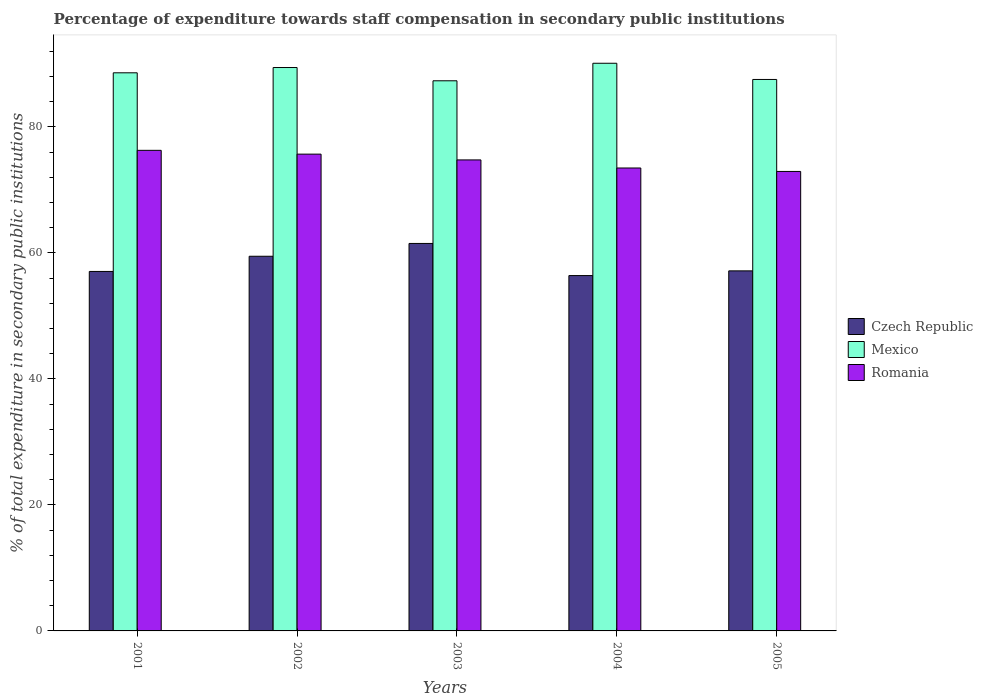How many different coloured bars are there?
Provide a short and direct response. 3. How many groups of bars are there?
Provide a succinct answer. 5. Are the number of bars per tick equal to the number of legend labels?
Make the answer very short. Yes. How many bars are there on the 1st tick from the left?
Keep it short and to the point. 3. What is the percentage of expenditure towards staff compensation in Romania in 2002?
Give a very brief answer. 75.67. Across all years, what is the maximum percentage of expenditure towards staff compensation in Mexico?
Your answer should be very brief. 90.09. Across all years, what is the minimum percentage of expenditure towards staff compensation in Czech Republic?
Offer a terse response. 56.39. In which year was the percentage of expenditure towards staff compensation in Czech Republic minimum?
Make the answer very short. 2004. What is the total percentage of expenditure towards staff compensation in Czech Republic in the graph?
Provide a short and direct response. 291.53. What is the difference between the percentage of expenditure towards staff compensation in Czech Republic in 2001 and that in 2002?
Make the answer very short. -2.41. What is the difference between the percentage of expenditure towards staff compensation in Romania in 2001 and the percentage of expenditure towards staff compensation in Czech Republic in 2004?
Your answer should be very brief. 19.88. What is the average percentage of expenditure towards staff compensation in Romania per year?
Give a very brief answer. 74.61. In the year 2002, what is the difference between the percentage of expenditure towards staff compensation in Czech Republic and percentage of expenditure towards staff compensation in Mexico?
Keep it short and to the point. -29.95. What is the ratio of the percentage of expenditure towards staff compensation in Mexico in 2001 to that in 2004?
Your response must be concise. 0.98. Is the percentage of expenditure towards staff compensation in Czech Republic in 2003 less than that in 2005?
Offer a very short reply. No. What is the difference between the highest and the second highest percentage of expenditure towards staff compensation in Mexico?
Make the answer very short. 0.68. What is the difference between the highest and the lowest percentage of expenditure towards staff compensation in Mexico?
Keep it short and to the point. 2.78. In how many years, is the percentage of expenditure towards staff compensation in Czech Republic greater than the average percentage of expenditure towards staff compensation in Czech Republic taken over all years?
Offer a very short reply. 2. Is the sum of the percentage of expenditure towards staff compensation in Romania in 2001 and 2004 greater than the maximum percentage of expenditure towards staff compensation in Czech Republic across all years?
Ensure brevity in your answer.  Yes. What does the 2nd bar from the left in 2005 represents?
Your answer should be very brief. Mexico. What does the 3rd bar from the right in 2005 represents?
Give a very brief answer. Czech Republic. Is it the case that in every year, the sum of the percentage of expenditure towards staff compensation in Czech Republic and percentage of expenditure towards staff compensation in Romania is greater than the percentage of expenditure towards staff compensation in Mexico?
Your response must be concise. Yes. How many bars are there?
Provide a succinct answer. 15. Are the values on the major ticks of Y-axis written in scientific E-notation?
Make the answer very short. No. Does the graph contain any zero values?
Your answer should be very brief. No. Where does the legend appear in the graph?
Give a very brief answer. Center right. How many legend labels are there?
Provide a short and direct response. 3. What is the title of the graph?
Provide a succinct answer. Percentage of expenditure towards staff compensation in secondary public institutions. Does "Tunisia" appear as one of the legend labels in the graph?
Make the answer very short. No. What is the label or title of the X-axis?
Ensure brevity in your answer.  Years. What is the label or title of the Y-axis?
Keep it short and to the point. % of total expenditure in secondary public institutions. What is the % of total expenditure in secondary public institutions of Czech Republic in 2001?
Provide a short and direct response. 57.05. What is the % of total expenditure in secondary public institutions in Mexico in 2001?
Make the answer very short. 88.57. What is the % of total expenditure in secondary public institutions of Romania in 2001?
Your answer should be very brief. 76.27. What is the % of total expenditure in secondary public institutions of Czech Republic in 2002?
Ensure brevity in your answer.  59.46. What is the % of total expenditure in secondary public institutions in Mexico in 2002?
Provide a succinct answer. 89.41. What is the % of total expenditure in secondary public institutions of Romania in 2002?
Provide a succinct answer. 75.67. What is the % of total expenditure in secondary public institutions of Czech Republic in 2003?
Your response must be concise. 61.49. What is the % of total expenditure in secondary public institutions of Mexico in 2003?
Offer a terse response. 87.31. What is the % of total expenditure in secondary public institutions of Romania in 2003?
Your response must be concise. 74.75. What is the % of total expenditure in secondary public institutions in Czech Republic in 2004?
Offer a very short reply. 56.39. What is the % of total expenditure in secondary public institutions in Mexico in 2004?
Give a very brief answer. 90.09. What is the % of total expenditure in secondary public institutions of Romania in 2004?
Make the answer very short. 73.47. What is the % of total expenditure in secondary public institutions of Czech Republic in 2005?
Keep it short and to the point. 57.14. What is the % of total expenditure in secondary public institutions in Mexico in 2005?
Provide a short and direct response. 87.52. What is the % of total expenditure in secondary public institutions of Romania in 2005?
Make the answer very short. 72.92. Across all years, what is the maximum % of total expenditure in secondary public institutions in Czech Republic?
Make the answer very short. 61.49. Across all years, what is the maximum % of total expenditure in secondary public institutions in Mexico?
Your answer should be compact. 90.09. Across all years, what is the maximum % of total expenditure in secondary public institutions of Romania?
Your answer should be very brief. 76.27. Across all years, what is the minimum % of total expenditure in secondary public institutions in Czech Republic?
Provide a succinct answer. 56.39. Across all years, what is the minimum % of total expenditure in secondary public institutions of Mexico?
Offer a terse response. 87.31. Across all years, what is the minimum % of total expenditure in secondary public institutions of Romania?
Offer a very short reply. 72.92. What is the total % of total expenditure in secondary public institutions of Czech Republic in the graph?
Provide a succinct answer. 291.53. What is the total % of total expenditure in secondary public institutions in Mexico in the graph?
Ensure brevity in your answer.  442.89. What is the total % of total expenditure in secondary public institutions of Romania in the graph?
Offer a very short reply. 373.07. What is the difference between the % of total expenditure in secondary public institutions in Czech Republic in 2001 and that in 2002?
Provide a succinct answer. -2.41. What is the difference between the % of total expenditure in secondary public institutions in Mexico in 2001 and that in 2002?
Provide a succinct answer. -0.84. What is the difference between the % of total expenditure in secondary public institutions of Romania in 2001 and that in 2002?
Ensure brevity in your answer.  0.6. What is the difference between the % of total expenditure in secondary public institutions of Czech Republic in 2001 and that in 2003?
Your answer should be compact. -4.45. What is the difference between the % of total expenditure in secondary public institutions of Mexico in 2001 and that in 2003?
Ensure brevity in your answer.  1.27. What is the difference between the % of total expenditure in secondary public institutions of Romania in 2001 and that in 2003?
Offer a very short reply. 1.52. What is the difference between the % of total expenditure in secondary public institutions of Czech Republic in 2001 and that in 2004?
Give a very brief answer. 0.65. What is the difference between the % of total expenditure in secondary public institutions in Mexico in 2001 and that in 2004?
Give a very brief answer. -1.51. What is the difference between the % of total expenditure in secondary public institutions of Romania in 2001 and that in 2004?
Your response must be concise. 2.8. What is the difference between the % of total expenditure in secondary public institutions of Czech Republic in 2001 and that in 2005?
Make the answer very short. -0.09. What is the difference between the % of total expenditure in secondary public institutions in Mexico in 2001 and that in 2005?
Your answer should be very brief. 1.06. What is the difference between the % of total expenditure in secondary public institutions of Romania in 2001 and that in 2005?
Make the answer very short. 3.35. What is the difference between the % of total expenditure in secondary public institutions of Czech Republic in 2002 and that in 2003?
Make the answer very short. -2.04. What is the difference between the % of total expenditure in secondary public institutions of Mexico in 2002 and that in 2003?
Make the answer very short. 2.1. What is the difference between the % of total expenditure in secondary public institutions in Romania in 2002 and that in 2003?
Offer a terse response. 0.92. What is the difference between the % of total expenditure in secondary public institutions of Czech Republic in 2002 and that in 2004?
Make the answer very short. 3.06. What is the difference between the % of total expenditure in secondary public institutions of Mexico in 2002 and that in 2004?
Make the answer very short. -0.68. What is the difference between the % of total expenditure in secondary public institutions of Romania in 2002 and that in 2004?
Keep it short and to the point. 2.2. What is the difference between the % of total expenditure in secondary public institutions of Czech Republic in 2002 and that in 2005?
Keep it short and to the point. 2.32. What is the difference between the % of total expenditure in secondary public institutions in Mexico in 2002 and that in 2005?
Ensure brevity in your answer.  1.89. What is the difference between the % of total expenditure in secondary public institutions of Romania in 2002 and that in 2005?
Provide a succinct answer. 2.75. What is the difference between the % of total expenditure in secondary public institutions in Czech Republic in 2003 and that in 2004?
Provide a succinct answer. 5.1. What is the difference between the % of total expenditure in secondary public institutions of Mexico in 2003 and that in 2004?
Offer a terse response. -2.78. What is the difference between the % of total expenditure in secondary public institutions of Romania in 2003 and that in 2004?
Make the answer very short. 1.28. What is the difference between the % of total expenditure in secondary public institutions of Czech Republic in 2003 and that in 2005?
Your response must be concise. 4.35. What is the difference between the % of total expenditure in secondary public institutions of Mexico in 2003 and that in 2005?
Your response must be concise. -0.21. What is the difference between the % of total expenditure in secondary public institutions in Romania in 2003 and that in 2005?
Your answer should be compact. 1.83. What is the difference between the % of total expenditure in secondary public institutions of Czech Republic in 2004 and that in 2005?
Keep it short and to the point. -0.75. What is the difference between the % of total expenditure in secondary public institutions in Mexico in 2004 and that in 2005?
Your response must be concise. 2.57. What is the difference between the % of total expenditure in secondary public institutions in Romania in 2004 and that in 2005?
Your answer should be very brief. 0.55. What is the difference between the % of total expenditure in secondary public institutions in Czech Republic in 2001 and the % of total expenditure in secondary public institutions in Mexico in 2002?
Make the answer very short. -32.36. What is the difference between the % of total expenditure in secondary public institutions in Czech Republic in 2001 and the % of total expenditure in secondary public institutions in Romania in 2002?
Give a very brief answer. -18.62. What is the difference between the % of total expenditure in secondary public institutions in Mexico in 2001 and the % of total expenditure in secondary public institutions in Romania in 2002?
Ensure brevity in your answer.  12.91. What is the difference between the % of total expenditure in secondary public institutions of Czech Republic in 2001 and the % of total expenditure in secondary public institutions of Mexico in 2003?
Your response must be concise. -30.26. What is the difference between the % of total expenditure in secondary public institutions of Czech Republic in 2001 and the % of total expenditure in secondary public institutions of Romania in 2003?
Provide a short and direct response. -17.7. What is the difference between the % of total expenditure in secondary public institutions in Mexico in 2001 and the % of total expenditure in secondary public institutions in Romania in 2003?
Your response must be concise. 13.82. What is the difference between the % of total expenditure in secondary public institutions of Czech Republic in 2001 and the % of total expenditure in secondary public institutions of Mexico in 2004?
Ensure brevity in your answer.  -33.04. What is the difference between the % of total expenditure in secondary public institutions in Czech Republic in 2001 and the % of total expenditure in secondary public institutions in Romania in 2004?
Keep it short and to the point. -16.42. What is the difference between the % of total expenditure in secondary public institutions in Mexico in 2001 and the % of total expenditure in secondary public institutions in Romania in 2004?
Make the answer very short. 15.11. What is the difference between the % of total expenditure in secondary public institutions of Czech Republic in 2001 and the % of total expenditure in secondary public institutions of Mexico in 2005?
Your answer should be very brief. -30.47. What is the difference between the % of total expenditure in secondary public institutions in Czech Republic in 2001 and the % of total expenditure in secondary public institutions in Romania in 2005?
Offer a terse response. -15.87. What is the difference between the % of total expenditure in secondary public institutions in Mexico in 2001 and the % of total expenditure in secondary public institutions in Romania in 2005?
Your answer should be compact. 15.66. What is the difference between the % of total expenditure in secondary public institutions in Czech Republic in 2002 and the % of total expenditure in secondary public institutions in Mexico in 2003?
Your answer should be very brief. -27.85. What is the difference between the % of total expenditure in secondary public institutions of Czech Republic in 2002 and the % of total expenditure in secondary public institutions of Romania in 2003?
Offer a very short reply. -15.29. What is the difference between the % of total expenditure in secondary public institutions of Mexico in 2002 and the % of total expenditure in secondary public institutions of Romania in 2003?
Provide a succinct answer. 14.66. What is the difference between the % of total expenditure in secondary public institutions in Czech Republic in 2002 and the % of total expenditure in secondary public institutions in Mexico in 2004?
Make the answer very short. -30.63. What is the difference between the % of total expenditure in secondary public institutions in Czech Republic in 2002 and the % of total expenditure in secondary public institutions in Romania in 2004?
Your response must be concise. -14.01. What is the difference between the % of total expenditure in secondary public institutions in Mexico in 2002 and the % of total expenditure in secondary public institutions in Romania in 2004?
Your answer should be compact. 15.94. What is the difference between the % of total expenditure in secondary public institutions in Czech Republic in 2002 and the % of total expenditure in secondary public institutions in Mexico in 2005?
Keep it short and to the point. -28.06. What is the difference between the % of total expenditure in secondary public institutions of Czech Republic in 2002 and the % of total expenditure in secondary public institutions of Romania in 2005?
Your answer should be compact. -13.46. What is the difference between the % of total expenditure in secondary public institutions in Mexico in 2002 and the % of total expenditure in secondary public institutions in Romania in 2005?
Give a very brief answer. 16.49. What is the difference between the % of total expenditure in secondary public institutions in Czech Republic in 2003 and the % of total expenditure in secondary public institutions in Mexico in 2004?
Provide a short and direct response. -28.59. What is the difference between the % of total expenditure in secondary public institutions of Czech Republic in 2003 and the % of total expenditure in secondary public institutions of Romania in 2004?
Keep it short and to the point. -11.97. What is the difference between the % of total expenditure in secondary public institutions in Mexico in 2003 and the % of total expenditure in secondary public institutions in Romania in 2004?
Give a very brief answer. 13.84. What is the difference between the % of total expenditure in secondary public institutions in Czech Republic in 2003 and the % of total expenditure in secondary public institutions in Mexico in 2005?
Ensure brevity in your answer.  -26.02. What is the difference between the % of total expenditure in secondary public institutions in Czech Republic in 2003 and the % of total expenditure in secondary public institutions in Romania in 2005?
Provide a short and direct response. -11.42. What is the difference between the % of total expenditure in secondary public institutions of Mexico in 2003 and the % of total expenditure in secondary public institutions of Romania in 2005?
Your response must be concise. 14.39. What is the difference between the % of total expenditure in secondary public institutions of Czech Republic in 2004 and the % of total expenditure in secondary public institutions of Mexico in 2005?
Your response must be concise. -31.12. What is the difference between the % of total expenditure in secondary public institutions of Czech Republic in 2004 and the % of total expenditure in secondary public institutions of Romania in 2005?
Ensure brevity in your answer.  -16.52. What is the difference between the % of total expenditure in secondary public institutions of Mexico in 2004 and the % of total expenditure in secondary public institutions of Romania in 2005?
Offer a very short reply. 17.17. What is the average % of total expenditure in secondary public institutions in Czech Republic per year?
Your answer should be compact. 58.31. What is the average % of total expenditure in secondary public institutions in Mexico per year?
Make the answer very short. 88.58. What is the average % of total expenditure in secondary public institutions of Romania per year?
Your answer should be compact. 74.61. In the year 2001, what is the difference between the % of total expenditure in secondary public institutions of Czech Republic and % of total expenditure in secondary public institutions of Mexico?
Provide a succinct answer. -31.52. In the year 2001, what is the difference between the % of total expenditure in secondary public institutions of Czech Republic and % of total expenditure in secondary public institutions of Romania?
Make the answer very short. -19.22. In the year 2001, what is the difference between the % of total expenditure in secondary public institutions of Mexico and % of total expenditure in secondary public institutions of Romania?
Make the answer very short. 12.3. In the year 2002, what is the difference between the % of total expenditure in secondary public institutions of Czech Republic and % of total expenditure in secondary public institutions of Mexico?
Make the answer very short. -29.95. In the year 2002, what is the difference between the % of total expenditure in secondary public institutions in Czech Republic and % of total expenditure in secondary public institutions in Romania?
Make the answer very short. -16.21. In the year 2002, what is the difference between the % of total expenditure in secondary public institutions in Mexico and % of total expenditure in secondary public institutions in Romania?
Your response must be concise. 13.74. In the year 2003, what is the difference between the % of total expenditure in secondary public institutions in Czech Republic and % of total expenditure in secondary public institutions in Mexico?
Provide a short and direct response. -25.81. In the year 2003, what is the difference between the % of total expenditure in secondary public institutions in Czech Republic and % of total expenditure in secondary public institutions in Romania?
Make the answer very short. -13.26. In the year 2003, what is the difference between the % of total expenditure in secondary public institutions of Mexico and % of total expenditure in secondary public institutions of Romania?
Your answer should be very brief. 12.56. In the year 2004, what is the difference between the % of total expenditure in secondary public institutions in Czech Republic and % of total expenditure in secondary public institutions in Mexico?
Offer a very short reply. -33.69. In the year 2004, what is the difference between the % of total expenditure in secondary public institutions of Czech Republic and % of total expenditure in secondary public institutions of Romania?
Offer a very short reply. -17.07. In the year 2004, what is the difference between the % of total expenditure in secondary public institutions in Mexico and % of total expenditure in secondary public institutions in Romania?
Give a very brief answer. 16.62. In the year 2005, what is the difference between the % of total expenditure in secondary public institutions of Czech Republic and % of total expenditure in secondary public institutions of Mexico?
Make the answer very short. -30.38. In the year 2005, what is the difference between the % of total expenditure in secondary public institutions of Czech Republic and % of total expenditure in secondary public institutions of Romania?
Ensure brevity in your answer.  -15.78. In the year 2005, what is the difference between the % of total expenditure in secondary public institutions in Mexico and % of total expenditure in secondary public institutions in Romania?
Keep it short and to the point. 14.6. What is the ratio of the % of total expenditure in secondary public institutions of Czech Republic in 2001 to that in 2002?
Provide a short and direct response. 0.96. What is the ratio of the % of total expenditure in secondary public institutions of Mexico in 2001 to that in 2002?
Offer a very short reply. 0.99. What is the ratio of the % of total expenditure in secondary public institutions in Czech Republic in 2001 to that in 2003?
Make the answer very short. 0.93. What is the ratio of the % of total expenditure in secondary public institutions in Mexico in 2001 to that in 2003?
Ensure brevity in your answer.  1.01. What is the ratio of the % of total expenditure in secondary public institutions of Romania in 2001 to that in 2003?
Your response must be concise. 1.02. What is the ratio of the % of total expenditure in secondary public institutions in Czech Republic in 2001 to that in 2004?
Offer a terse response. 1.01. What is the ratio of the % of total expenditure in secondary public institutions in Mexico in 2001 to that in 2004?
Your answer should be very brief. 0.98. What is the ratio of the % of total expenditure in secondary public institutions in Romania in 2001 to that in 2004?
Your answer should be very brief. 1.04. What is the ratio of the % of total expenditure in secondary public institutions in Czech Republic in 2001 to that in 2005?
Your response must be concise. 1. What is the ratio of the % of total expenditure in secondary public institutions in Mexico in 2001 to that in 2005?
Your response must be concise. 1.01. What is the ratio of the % of total expenditure in secondary public institutions of Romania in 2001 to that in 2005?
Make the answer very short. 1.05. What is the ratio of the % of total expenditure in secondary public institutions of Czech Republic in 2002 to that in 2003?
Your response must be concise. 0.97. What is the ratio of the % of total expenditure in secondary public institutions of Mexico in 2002 to that in 2003?
Give a very brief answer. 1.02. What is the ratio of the % of total expenditure in secondary public institutions in Romania in 2002 to that in 2003?
Keep it short and to the point. 1.01. What is the ratio of the % of total expenditure in secondary public institutions of Czech Republic in 2002 to that in 2004?
Your answer should be very brief. 1.05. What is the ratio of the % of total expenditure in secondary public institutions in Mexico in 2002 to that in 2004?
Give a very brief answer. 0.99. What is the ratio of the % of total expenditure in secondary public institutions in Romania in 2002 to that in 2004?
Your response must be concise. 1.03. What is the ratio of the % of total expenditure in secondary public institutions of Czech Republic in 2002 to that in 2005?
Ensure brevity in your answer.  1.04. What is the ratio of the % of total expenditure in secondary public institutions of Mexico in 2002 to that in 2005?
Ensure brevity in your answer.  1.02. What is the ratio of the % of total expenditure in secondary public institutions of Romania in 2002 to that in 2005?
Your answer should be compact. 1.04. What is the ratio of the % of total expenditure in secondary public institutions of Czech Republic in 2003 to that in 2004?
Give a very brief answer. 1.09. What is the ratio of the % of total expenditure in secondary public institutions in Mexico in 2003 to that in 2004?
Your response must be concise. 0.97. What is the ratio of the % of total expenditure in secondary public institutions in Romania in 2003 to that in 2004?
Your answer should be compact. 1.02. What is the ratio of the % of total expenditure in secondary public institutions in Czech Republic in 2003 to that in 2005?
Provide a succinct answer. 1.08. What is the ratio of the % of total expenditure in secondary public institutions in Romania in 2003 to that in 2005?
Make the answer very short. 1.03. What is the ratio of the % of total expenditure in secondary public institutions in Czech Republic in 2004 to that in 2005?
Ensure brevity in your answer.  0.99. What is the ratio of the % of total expenditure in secondary public institutions in Mexico in 2004 to that in 2005?
Your answer should be very brief. 1.03. What is the ratio of the % of total expenditure in secondary public institutions of Romania in 2004 to that in 2005?
Provide a succinct answer. 1.01. What is the difference between the highest and the second highest % of total expenditure in secondary public institutions of Czech Republic?
Keep it short and to the point. 2.04. What is the difference between the highest and the second highest % of total expenditure in secondary public institutions in Mexico?
Offer a very short reply. 0.68. What is the difference between the highest and the second highest % of total expenditure in secondary public institutions of Romania?
Offer a terse response. 0.6. What is the difference between the highest and the lowest % of total expenditure in secondary public institutions in Mexico?
Your answer should be compact. 2.78. What is the difference between the highest and the lowest % of total expenditure in secondary public institutions of Romania?
Provide a succinct answer. 3.35. 